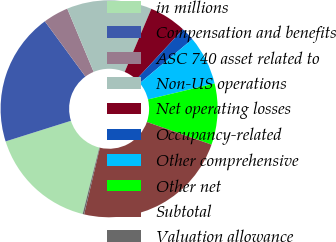Convert chart. <chart><loc_0><loc_0><loc_500><loc_500><pie_chart><fcel>in millions<fcel>Compensation and benefits<fcel>ASC 740 asset related to<fcel>Non-US operations<fcel>Net operating losses<fcel>Occupancy-related<fcel>Other comprehensive<fcel>Other net<fcel>Subtotal<fcel>Valuation allowance<nl><fcel>16.22%<fcel>19.78%<fcel>3.78%<fcel>12.67%<fcel>5.55%<fcel>2.0%<fcel>7.33%<fcel>9.11%<fcel>23.34%<fcel>0.22%<nl></chart> 